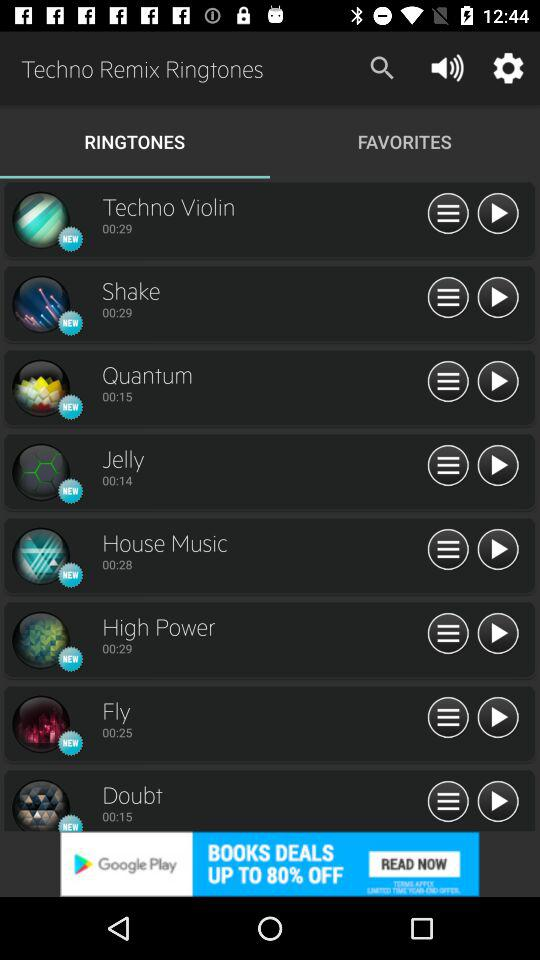What is the duration of the "Fly" ringtone? The duration of the "Fly" ringtone is 25 seconds. 